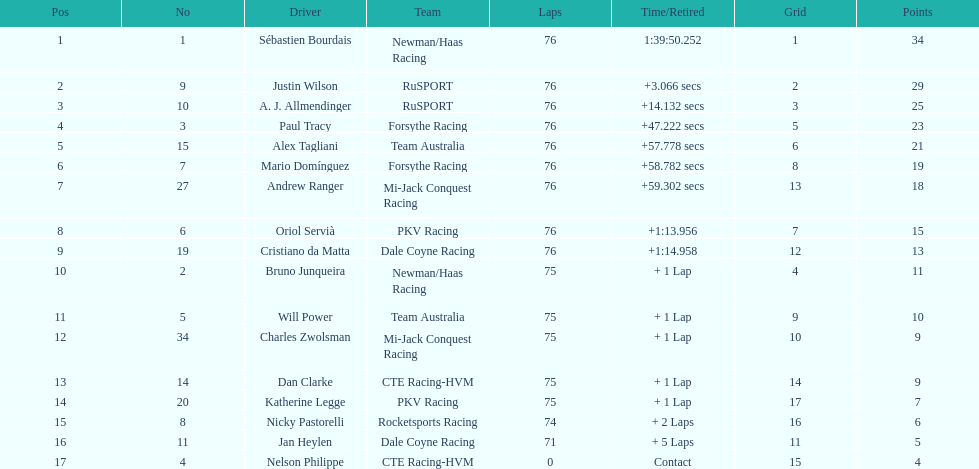How many drivers were competing for brazil? 2. 